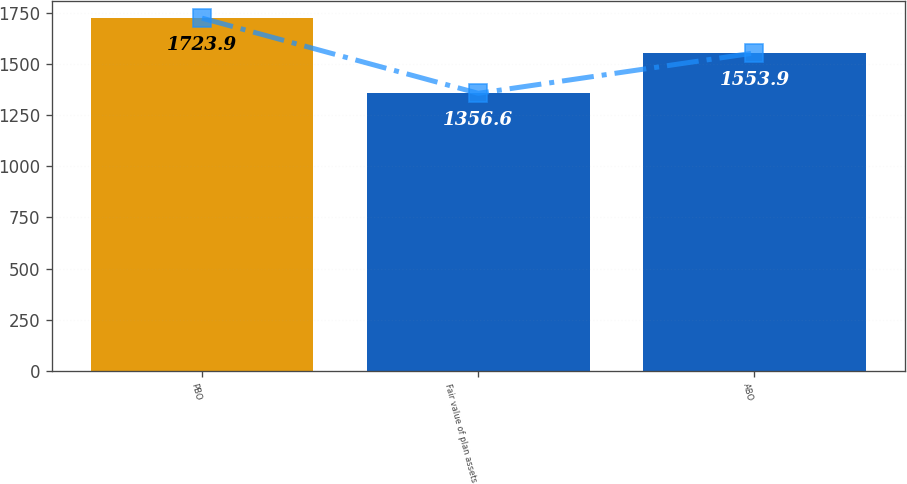Convert chart to OTSL. <chart><loc_0><loc_0><loc_500><loc_500><bar_chart><fcel>PBO<fcel>Fair value of plan assets<fcel>ABO<nl><fcel>1723.9<fcel>1356.6<fcel>1553.9<nl></chart> 